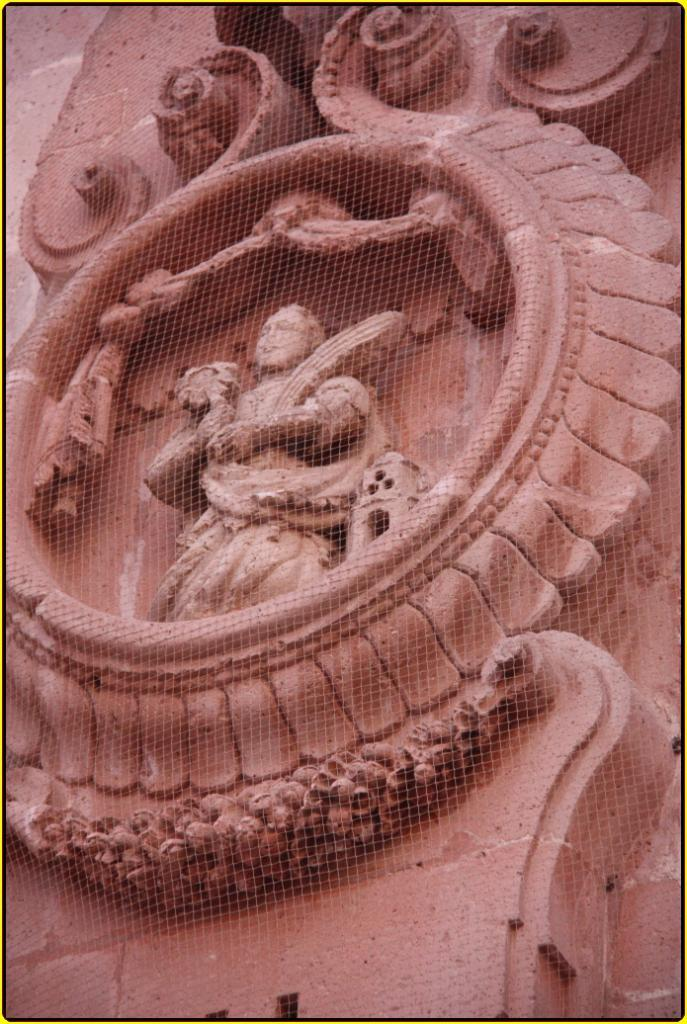What is the main subject of the image? There is a sculpture in the image. Where is the sculpture located? The sculpture is on a wall. Can you describe the sculpture's appearance? The sculpture has some designs. What type of ear is attached to the carriage in the image? There is no ear or carriage present in the image; it features a sculpture on a wall with designs. 